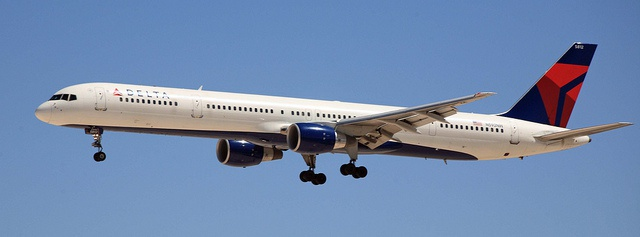Describe the objects in this image and their specific colors. I can see a airplane in gray, darkgray, black, and white tones in this image. 